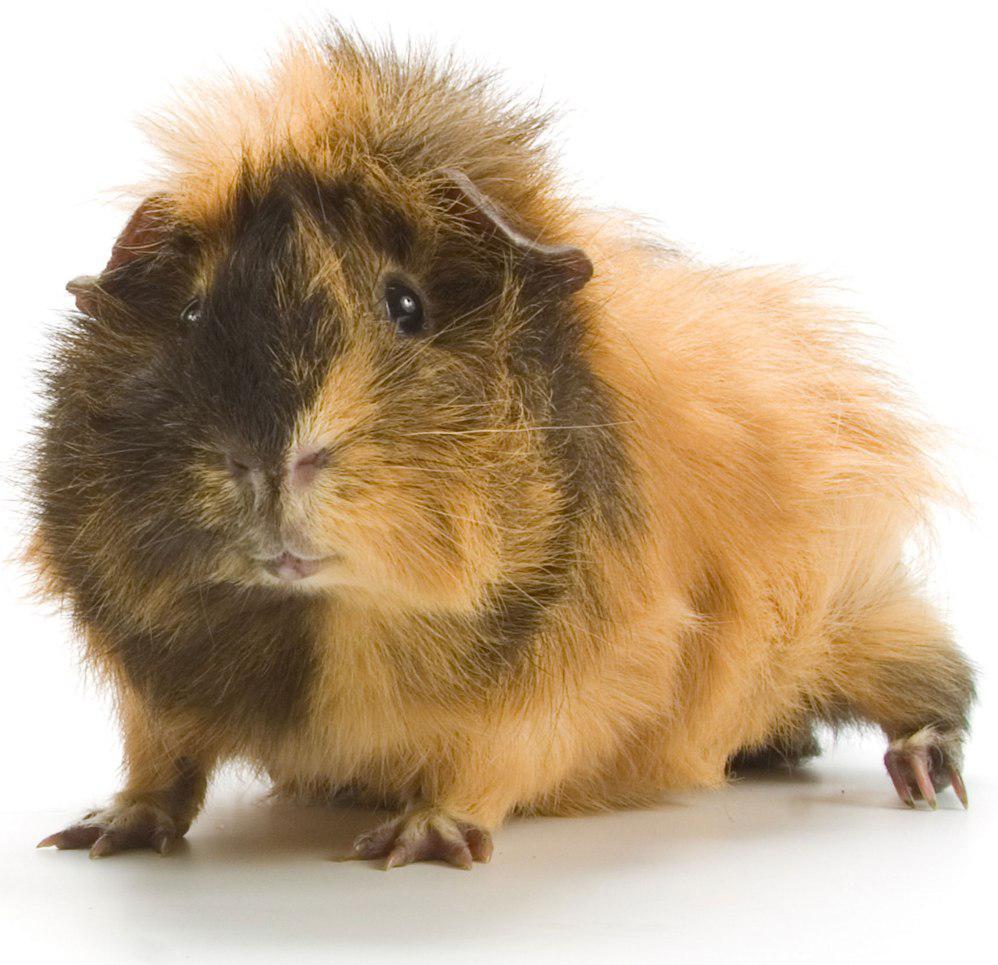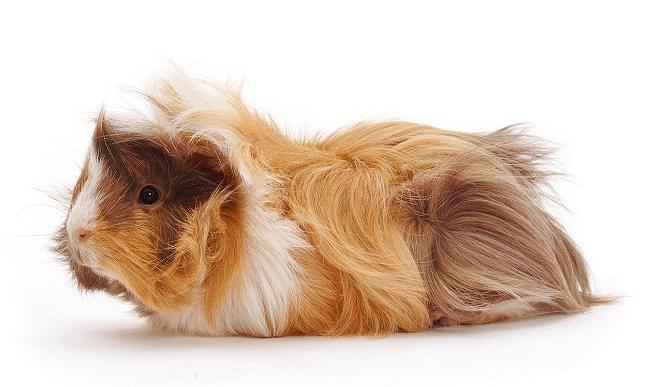The first image is the image on the left, the second image is the image on the right. Considering the images on both sides, is "One image contains twice as many guinea pigs as the other hamster, and one image contains something bright green." valid? Answer yes or no. No. The first image is the image on the left, the second image is the image on the right. Evaluate the accuracy of this statement regarding the images: "There are three guinea pigs.". Is it true? Answer yes or no. No. 